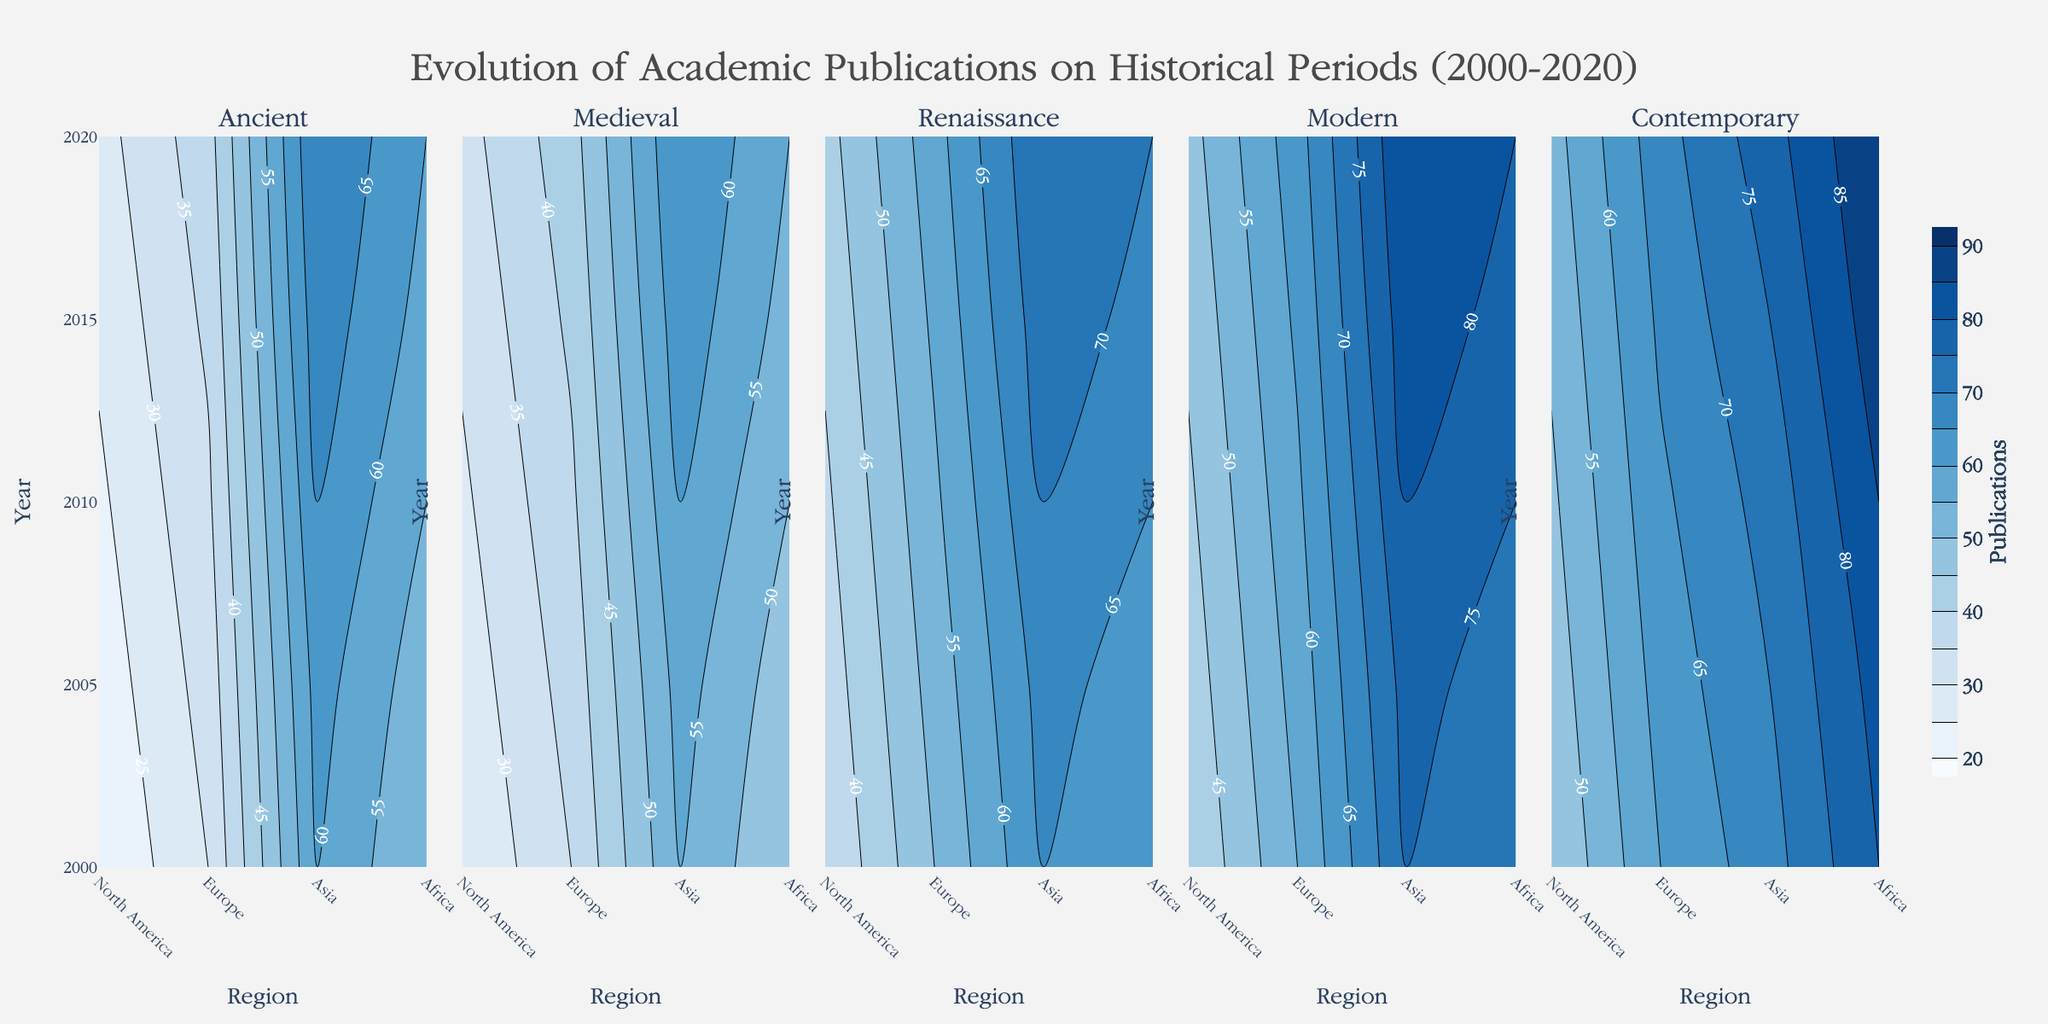What is the title of the figure? The title of the figure is displayed at the top of the plot. Its font size is larger and it is centered in the layout.
Answer: Evolution of Academic Publications on Historical Periods (2000-2020) Which region has the highest number of publications for the Ancient period in 2020? By examining the contour plot for the Ancient period and the labels, the y-axis for the year 2020 and x-axis for regions show the highest value. The highest contour for North America is 60, the highest for Europe is 70, for Asia is 38, and Africa is 28.
Answer: Europe How did the number of publications on the Medieval period in North America change from 2000 to 2020? By referring to the contour plot for the Medieval period, locate North America on the x-axis and compare the values over the years 2000 to 2020. The values increase from 45 (2000) to 47 (2005) to 50 (2010) to 53 (2015) to 55 (2020).
Answer: Increased Between which two periods did Asia see the largest growth in publications from 2000 to 2020? Analyzing the contour plots across all periods for Asia, comparing the change in values from 2000 to 2020 for each period. In 2000, Asia has 30 (Ancient), 35 (Medieval), 50 (Renaissance), 55 (Modern), 60 (Contemporary) and in 2020, 38 (Ancient), 43 (Medieval), 58 (Renaissance), 63 (Modern), 68 (Contemporary). The largest difference is in the Contemporary period: 68 - 60 = 8.
Answer: Contemporary Which historical period shows the least variation in the number of publications across all regions for 2020? Inspect the contour plots for 2020 across all periods. The least variation can be understood by closely observing the range of contour levels for each period. Ancient ranges from 28 to 70, Medieval from 33 to 65, Renaissance from 43 to 75, Modern from 48 to 85, and Contemporary from 53 to 90.
Answer: Medieval What is the absolute difference in the number of Modern period publications between North America and Europe in 2015? Locate the contour plot for the Modern period and compare values for North America and Europe in 2015. North America has 78 publications and Europe has 83. Calculate the difference: 83 - 78 = 5.
Answer: 5 Which region had the smallest increase in publications on the Renaissance period from 2000 to 2020? Focus on the Renaissance contour plot and compare values for all regions from 2000 to 2020. North America increased from 60 to 70, Europe from 65 to 75, Asia from 50 to 58, and Africa from 35 to 43. The smallest increase is for Asia: 58 - 50 = 8.
Answer: Africa Compared to 2010, did the publications on the Contemporary period in Europe increase or decrease by 2020, and by how much? In the Contemporary period contour plot for Europe, compare values between 2010 and 2020. In 2010, Europe has 72 publications, and in 2020, it has 78. Calculate the difference: 78 - 72 = 6.
Answer: Increased by 6 Which period and region combination had the maximum value in 2005? Analyze all contour plots for 2005 to locate the highest value across all regions and periods. North America has values ranging from 47 to 82, Europe from 57 to 77, Asia from 37 to 62, and Africa from 27 to 47. The highest is North America for Contemporary: 82.
Answer: Contemporary in North America Which period shows the highest average number of publications across all regions in 2020? Review the contour plots for 2020, calculate the average number of publications for each period across all regions. Add up the values and divide by the number of regions:
Ancient: (60+70+38+28)/4 = 49
Medieval: (55+65+43+33)/4 = 49
Renaissance: (70+75+58+43)/4 = 61.5
Modern: (80+85+63+48)/4 = 69
Contemporary: (90+78+68+53)/4 = 72.25.
Answer: Contemporary 